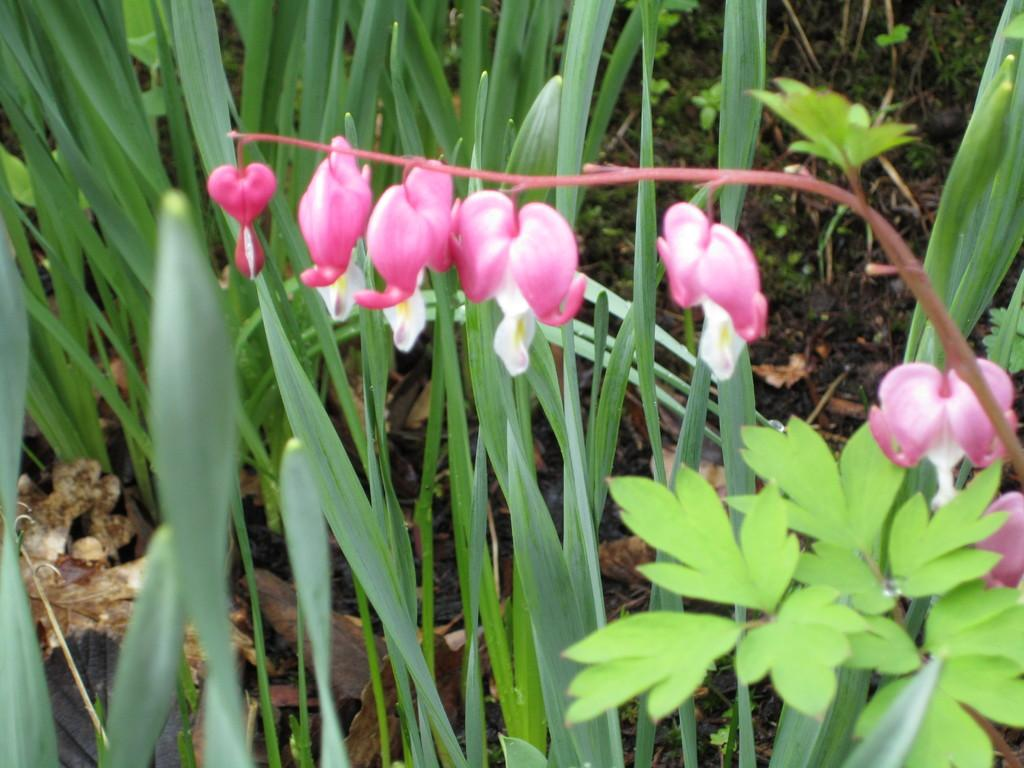What type of vegetation can be seen in the image? There are flowers, a plant, and grass visible in the image. Can you describe the plant in the image? The plant in the image is not specified, but it is present alongside the flowers and grass. What is the natural setting depicted in the image? The natural setting includes flowers, a plant, and grass. What type of peace symbol can be seen in the image? There is no peace symbol present in the image; it features flowers, a plant, and grass. Can you tell me how many stars are visible in the image? There are no stars present in the image; it features flowers, a plant, and grass. 